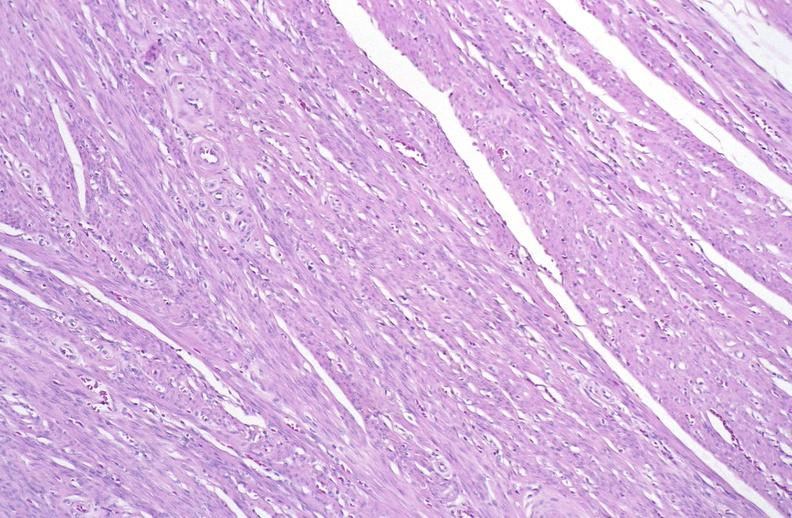s female reproductive present?
Answer the question using a single word or phrase. Yes 